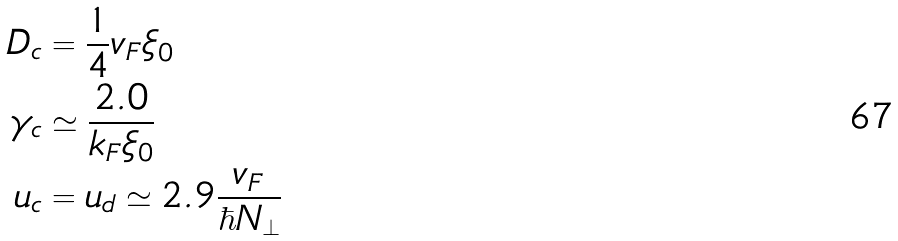Convert formula to latex. <formula><loc_0><loc_0><loc_500><loc_500>\ D _ { c } & = \frac { 1 } { 4 } v _ { F } \xi _ { 0 } \\ \gamma _ { c } & \simeq \frac { 2 . 0 } { k _ { F } \xi _ { 0 } } \\ u _ { c } & = u _ { d } \simeq 2 . 9 \frac { v _ { F } } { \hbar { N } _ { \perp } }</formula> 